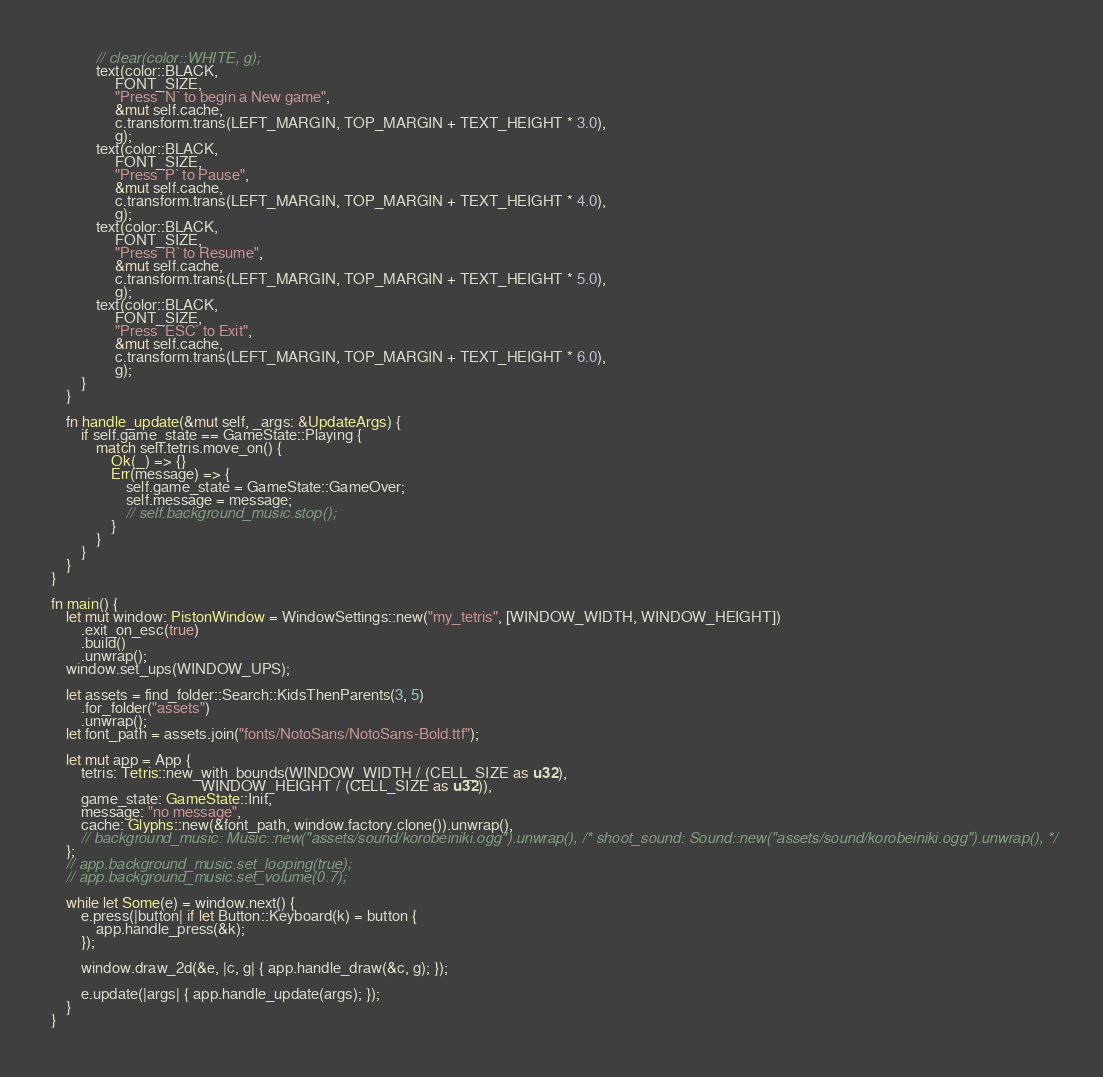Convert code to text. <code><loc_0><loc_0><loc_500><loc_500><_Rust_>            // clear(color::WHITE, g);
            text(color::BLACK,
                 FONT_SIZE,
                 "Press `N` to begin a New game",
                 &mut self.cache,
                 c.transform.trans(LEFT_MARGIN, TOP_MARGIN + TEXT_HEIGHT * 3.0),
                 g);
            text(color::BLACK,
                 FONT_SIZE,
                 "Press `P` to Pause",
                 &mut self.cache,
                 c.transform.trans(LEFT_MARGIN, TOP_MARGIN + TEXT_HEIGHT * 4.0),
                 g);
            text(color::BLACK,
                 FONT_SIZE,
                 "Press `R` to Resume",
                 &mut self.cache,
                 c.transform.trans(LEFT_MARGIN, TOP_MARGIN + TEXT_HEIGHT * 5.0),
                 g);
            text(color::BLACK,
                 FONT_SIZE,
                 "Press `ESC` to Exit",
                 &mut self.cache,
                 c.transform.trans(LEFT_MARGIN, TOP_MARGIN + TEXT_HEIGHT * 6.0),
                 g);
        }
    }

    fn handle_update(&mut self, _args: &UpdateArgs) {
        if self.game_state == GameState::Playing {
            match self.tetris.move_on() {
                Ok(_) => {}
                Err(message) => {
                    self.game_state = GameState::GameOver;
                    self.message = message;
                    // self.background_music.stop();
                }
            }
        }
    }
}

fn main() {
    let mut window: PistonWindow = WindowSettings::new("my_tetris", [WINDOW_WIDTH, WINDOW_HEIGHT])
        .exit_on_esc(true)
        .build()
        .unwrap();
    window.set_ups(WINDOW_UPS);

    let assets = find_folder::Search::KidsThenParents(3, 5)
        .for_folder("assets")
        .unwrap();
    let font_path = assets.join("fonts/NotoSans/NotoSans-Bold.ttf");

    let mut app = App {
        tetris: Tetris::new_with_bounds(WINDOW_WIDTH / (CELL_SIZE as u32),
                                        WINDOW_HEIGHT / (CELL_SIZE as u32)),
        game_state: GameState::Init,
        message: "no message",
        cache: Glyphs::new(&font_path, window.factory.clone()).unwrap(), 
        // background_music: Music::new("assets/sound/korobeiniki.ogg").unwrap(), /* shoot_sound: Sound::new("assets/sound/korobeiniki.ogg").unwrap(), */
    };
    // app.background_music.set_looping(true);
    // app.background_music.set_volume(0.7);

    while let Some(e) = window.next() {
        e.press(|button| if let Button::Keyboard(k) = button {
            app.handle_press(&k);
        });

        window.draw_2d(&e, |c, g| { app.handle_draw(&c, g); });

        e.update(|args| { app.handle_update(args); });
    }
}
</code> 